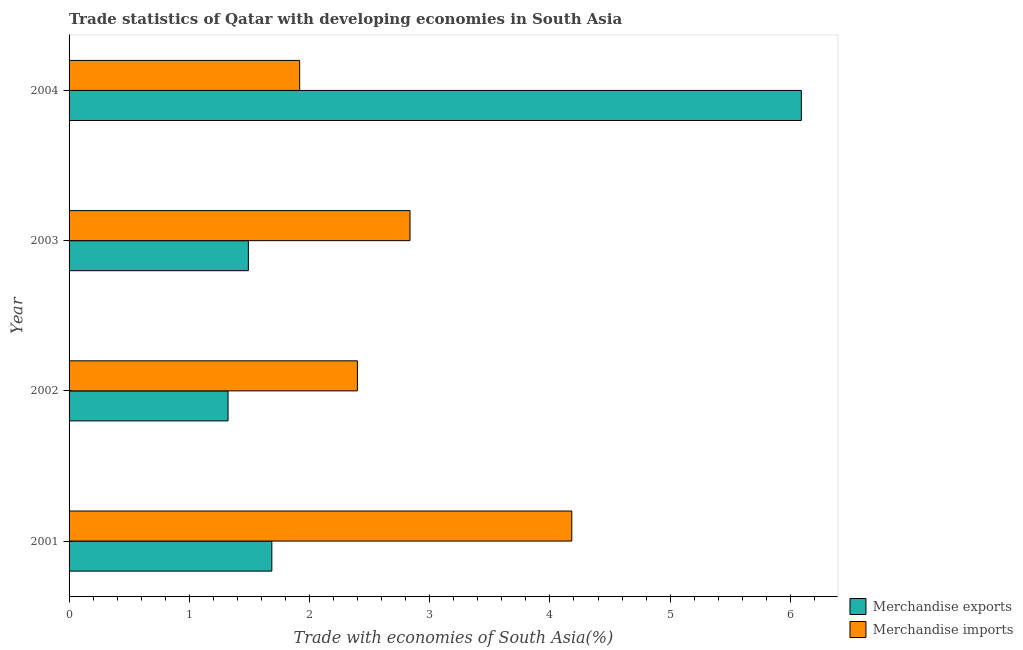How many different coloured bars are there?
Your answer should be very brief. 2. Are the number of bars on each tick of the Y-axis equal?
Your response must be concise. Yes. How many bars are there on the 1st tick from the bottom?
Your answer should be compact. 2. What is the label of the 2nd group of bars from the top?
Keep it short and to the point. 2003. In how many cases, is the number of bars for a given year not equal to the number of legend labels?
Offer a terse response. 0. What is the merchandise imports in 2001?
Make the answer very short. 4.18. Across all years, what is the maximum merchandise exports?
Keep it short and to the point. 6.09. Across all years, what is the minimum merchandise exports?
Keep it short and to the point. 1.32. What is the total merchandise imports in the graph?
Your answer should be compact. 11.34. What is the difference between the merchandise exports in 2001 and that in 2004?
Ensure brevity in your answer.  -4.41. What is the difference between the merchandise imports in 2001 and the merchandise exports in 2003?
Your response must be concise. 2.69. What is the average merchandise exports per year?
Provide a short and direct response. 2.65. In the year 2004, what is the difference between the merchandise exports and merchandise imports?
Keep it short and to the point. 4.17. Is the difference between the merchandise imports in 2003 and 2004 greater than the difference between the merchandise exports in 2003 and 2004?
Your response must be concise. Yes. What is the difference between the highest and the second highest merchandise exports?
Offer a very short reply. 4.41. What is the difference between the highest and the lowest merchandise imports?
Make the answer very short. 2.26. What does the 1st bar from the top in 2004 represents?
Provide a short and direct response. Merchandise imports. Are the values on the major ticks of X-axis written in scientific E-notation?
Your answer should be very brief. No. Does the graph contain grids?
Ensure brevity in your answer.  No. Where does the legend appear in the graph?
Your answer should be very brief. Bottom right. What is the title of the graph?
Give a very brief answer. Trade statistics of Qatar with developing economies in South Asia. What is the label or title of the X-axis?
Your answer should be compact. Trade with economies of South Asia(%). What is the label or title of the Y-axis?
Offer a terse response. Year. What is the Trade with economies of South Asia(%) in Merchandise exports in 2001?
Your answer should be very brief. 1.69. What is the Trade with economies of South Asia(%) in Merchandise imports in 2001?
Provide a succinct answer. 4.18. What is the Trade with economies of South Asia(%) in Merchandise exports in 2002?
Ensure brevity in your answer.  1.32. What is the Trade with economies of South Asia(%) of Merchandise imports in 2002?
Your answer should be compact. 2.4. What is the Trade with economies of South Asia(%) in Merchandise exports in 2003?
Give a very brief answer. 1.49. What is the Trade with economies of South Asia(%) in Merchandise imports in 2003?
Keep it short and to the point. 2.84. What is the Trade with economies of South Asia(%) in Merchandise exports in 2004?
Provide a short and direct response. 6.09. What is the Trade with economies of South Asia(%) of Merchandise imports in 2004?
Give a very brief answer. 1.92. Across all years, what is the maximum Trade with economies of South Asia(%) in Merchandise exports?
Ensure brevity in your answer.  6.09. Across all years, what is the maximum Trade with economies of South Asia(%) in Merchandise imports?
Your answer should be compact. 4.18. Across all years, what is the minimum Trade with economies of South Asia(%) in Merchandise exports?
Offer a terse response. 1.32. Across all years, what is the minimum Trade with economies of South Asia(%) of Merchandise imports?
Make the answer very short. 1.92. What is the total Trade with economies of South Asia(%) of Merchandise exports in the graph?
Your answer should be compact. 10.59. What is the total Trade with economies of South Asia(%) of Merchandise imports in the graph?
Your response must be concise. 11.34. What is the difference between the Trade with economies of South Asia(%) of Merchandise exports in 2001 and that in 2002?
Offer a terse response. 0.36. What is the difference between the Trade with economies of South Asia(%) in Merchandise imports in 2001 and that in 2002?
Make the answer very short. 1.78. What is the difference between the Trade with economies of South Asia(%) of Merchandise exports in 2001 and that in 2003?
Offer a very short reply. 0.2. What is the difference between the Trade with economies of South Asia(%) of Merchandise imports in 2001 and that in 2003?
Your answer should be very brief. 1.35. What is the difference between the Trade with economies of South Asia(%) of Merchandise exports in 2001 and that in 2004?
Keep it short and to the point. -4.4. What is the difference between the Trade with economies of South Asia(%) of Merchandise imports in 2001 and that in 2004?
Ensure brevity in your answer.  2.26. What is the difference between the Trade with economies of South Asia(%) in Merchandise exports in 2002 and that in 2003?
Keep it short and to the point. -0.17. What is the difference between the Trade with economies of South Asia(%) in Merchandise imports in 2002 and that in 2003?
Offer a very short reply. -0.44. What is the difference between the Trade with economies of South Asia(%) of Merchandise exports in 2002 and that in 2004?
Provide a short and direct response. -4.77. What is the difference between the Trade with economies of South Asia(%) in Merchandise imports in 2002 and that in 2004?
Give a very brief answer. 0.48. What is the difference between the Trade with economies of South Asia(%) of Merchandise exports in 2003 and that in 2004?
Offer a very short reply. -4.6. What is the difference between the Trade with economies of South Asia(%) in Merchandise imports in 2003 and that in 2004?
Keep it short and to the point. 0.92. What is the difference between the Trade with economies of South Asia(%) in Merchandise exports in 2001 and the Trade with economies of South Asia(%) in Merchandise imports in 2002?
Provide a short and direct response. -0.71. What is the difference between the Trade with economies of South Asia(%) of Merchandise exports in 2001 and the Trade with economies of South Asia(%) of Merchandise imports in 2003?
Keep it short and to the point. -1.15. What is the difference between the Trade with economies of South Asia(%) of Merchandise exports in 2001 and the Trade with economies of South Asia(%) of Merchandise imports in 2004?
Your answer should be very brief. -0.23. What is the difference between the Trade with economies of South Asia(%) in Merchandise exports in 2002 and the Trade with economies of South Asia(%) in Merchandise imports in 2003?
Offer a terse response. -1.51. What is the difference between the Trade with economies of South Asia(%) of Merchandise exports in 2002 and the Trade with economies of South Asia(%) of Merchandise imports in 2004?
Your answer should be very brief. -0.6. What is the difference between the Trade with economies of South Asia(%) in Merchandise exports in 2003 and the Trade with economies of South Asia(%) in Merchandise imports in 2004?
Give a very brief answer. -0.43. What is the average Trade with economies of South Asia(%) of Merchandise exports per year?
Make the answer very short. 2.65. What is the average Trade with economies of South Asia(%) in Merchandise imports per year?
Your answer should be compact. 2.83. In the year 2001, what is the difference between the Trade with economies of South Asia(%) in Merchandise exports and Trade with economies of South Asia(%) in Merchandise imports?
Keep it short and to the point. -2.5. In the year 2002, what is the difference between the Trade with economies of South Asia(%) of Merchandise exports and Trade with economies of South Asia(%) of Merchandise imports?
Your answer should be compact. -1.08. In the year 2003, what is the difference between the Trade with economies of South Asia(%) of Merchandise exports and Trade with economies of South Asia(%) of Merchandise imports?
Ensure brevity in your answer.  -1.34. In the year 2004, what is the difference between the Trade with economies of South Asia(%) in Merchandise exports and Trade with economies of South Asia(%) in Merchandise imports?
Your answer should be very brief. 4.17. What is the ratio of the Trade with economies of South Asia(%) in Merchandise exports in 2001 to that in 2002?
Provide a short and direct response. 1.28. What is the ratio of the Trade with economies of South Asia(%) in Merchandise imports in 2001 to that in 2002?
Make the answer very short. 1.74. What is the ratio of the Trade with economies of South Asia(%) in Merchandise exports in 2001 to that in 2003?
Your response must be concise. 1.13. What is the ratio of the Trade with economies of South Asia(%) in Merchandise imports in 2001 to that in 2003?
Provide a short and direct response. 1.47. What is the ratio of the Trade with economies of South Asia(%) in Merchandise exports in 2001 to that in 2004?
Your response must be concise. 0.28. What is the ratio of the Trade with economies of South Asia(%) in Merchandise imports in 2001 to that in 2004?
Your answer should be compact. 2.18. What is the ratio of the Trade with economies of South Asia(%) in Merchandise exports in 2002 to that in 2003?
Keep it short and to the point. 0.89. What is the ratio of the Trade with economies of South Asia(%) in Merchandise imports in 2002 to that in 2003?
Offer a very short reply. 0.85. What is the ratio of the Trade with economies of South Asia(%) of Merchandise exports in 2002 to that in 2004?
Give a very brief answer. 0.22. What is the ratio of the Trade with economies of South Asia(%) of Merchandise imports in 2002 to that in 2004?
Provide a succinct answer. 1.25. What is the ratio of the Trade with economies of South Asia(%) of Merchandise exports in 2003 to that in 2004?
Make the answer very short. 0.24. What is the ratio of the Trade with economies of South Asia(%) in Merchandise imports in 2003 to that in 2004?
Your response must be concise. 1.48. What is the difference between the highest and the second highest Trade with economies of South Asia(%) in Merchandise exports?
Give a very brief answer. 4.4. What is the difference between the highest and the second highest Trade with economies of South Asia(%) in Merchandise imports?
Provide a succinct answer. 1.35. What is the difference between the highest and the lowest Trade with economies of South Asia(%) in Merchandise exports?
Your answer should be compact. 4.77. What is the difference between the highest and the lowest Trade with economies of South Asia(%) of Merchandise imports?
Your response must be concise. 2.26. 